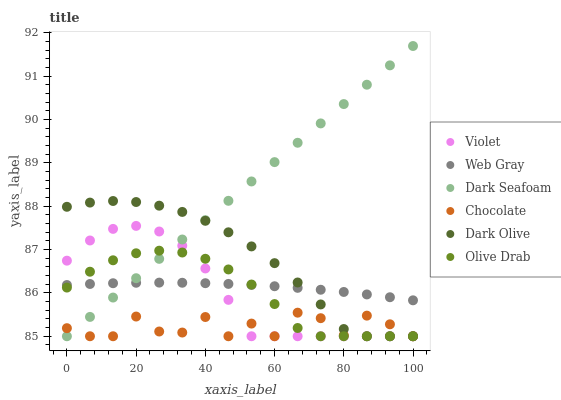Does Chocolate have the minimum area under the curve?
Answer yes or no. Yes. Does Dark Seafoam have the maximum area under the curve?
Answer yes or no. Yes. Does Dark Olive have the minimum area under the curve?
Answer yes or no. No. Does Dark Olive have the maximum area under the curve?
Answer yes or no. No. Is Dark Seafoam the smoothest?
Answer yes or no. Yes. Is Chocolate the roughest?
Answer yes or no. Yes. Is Dark Olive the smoothest?
Answer yes or no. No. Is Dark Olive the roughest?
Answer yes or no. No. Does Dark Olive have the lowest value?
Answer yes or no. Yes. Does Dark Seafoam have the highest value?
Answer yes or no. Yes. Does Dark Olive have the highest value?
Answer yes or no. No. Is Chocolate less than Web Gray?
Answer yes or no. Yes. Is Web Gray greater than Chocolate?
Answer yes or no. Yes. Does Dark Seafoam intersect Dark Olive?
Answer yes or no. Yes. Is Dark Seafoam less than Dark Olive?
Answer yes or no. No. Is Dark Seafoam greater than Dark Olive?
Answer yes or no. No. Does Chocolate intersect Web Gray?
Answer yes or no. No. 